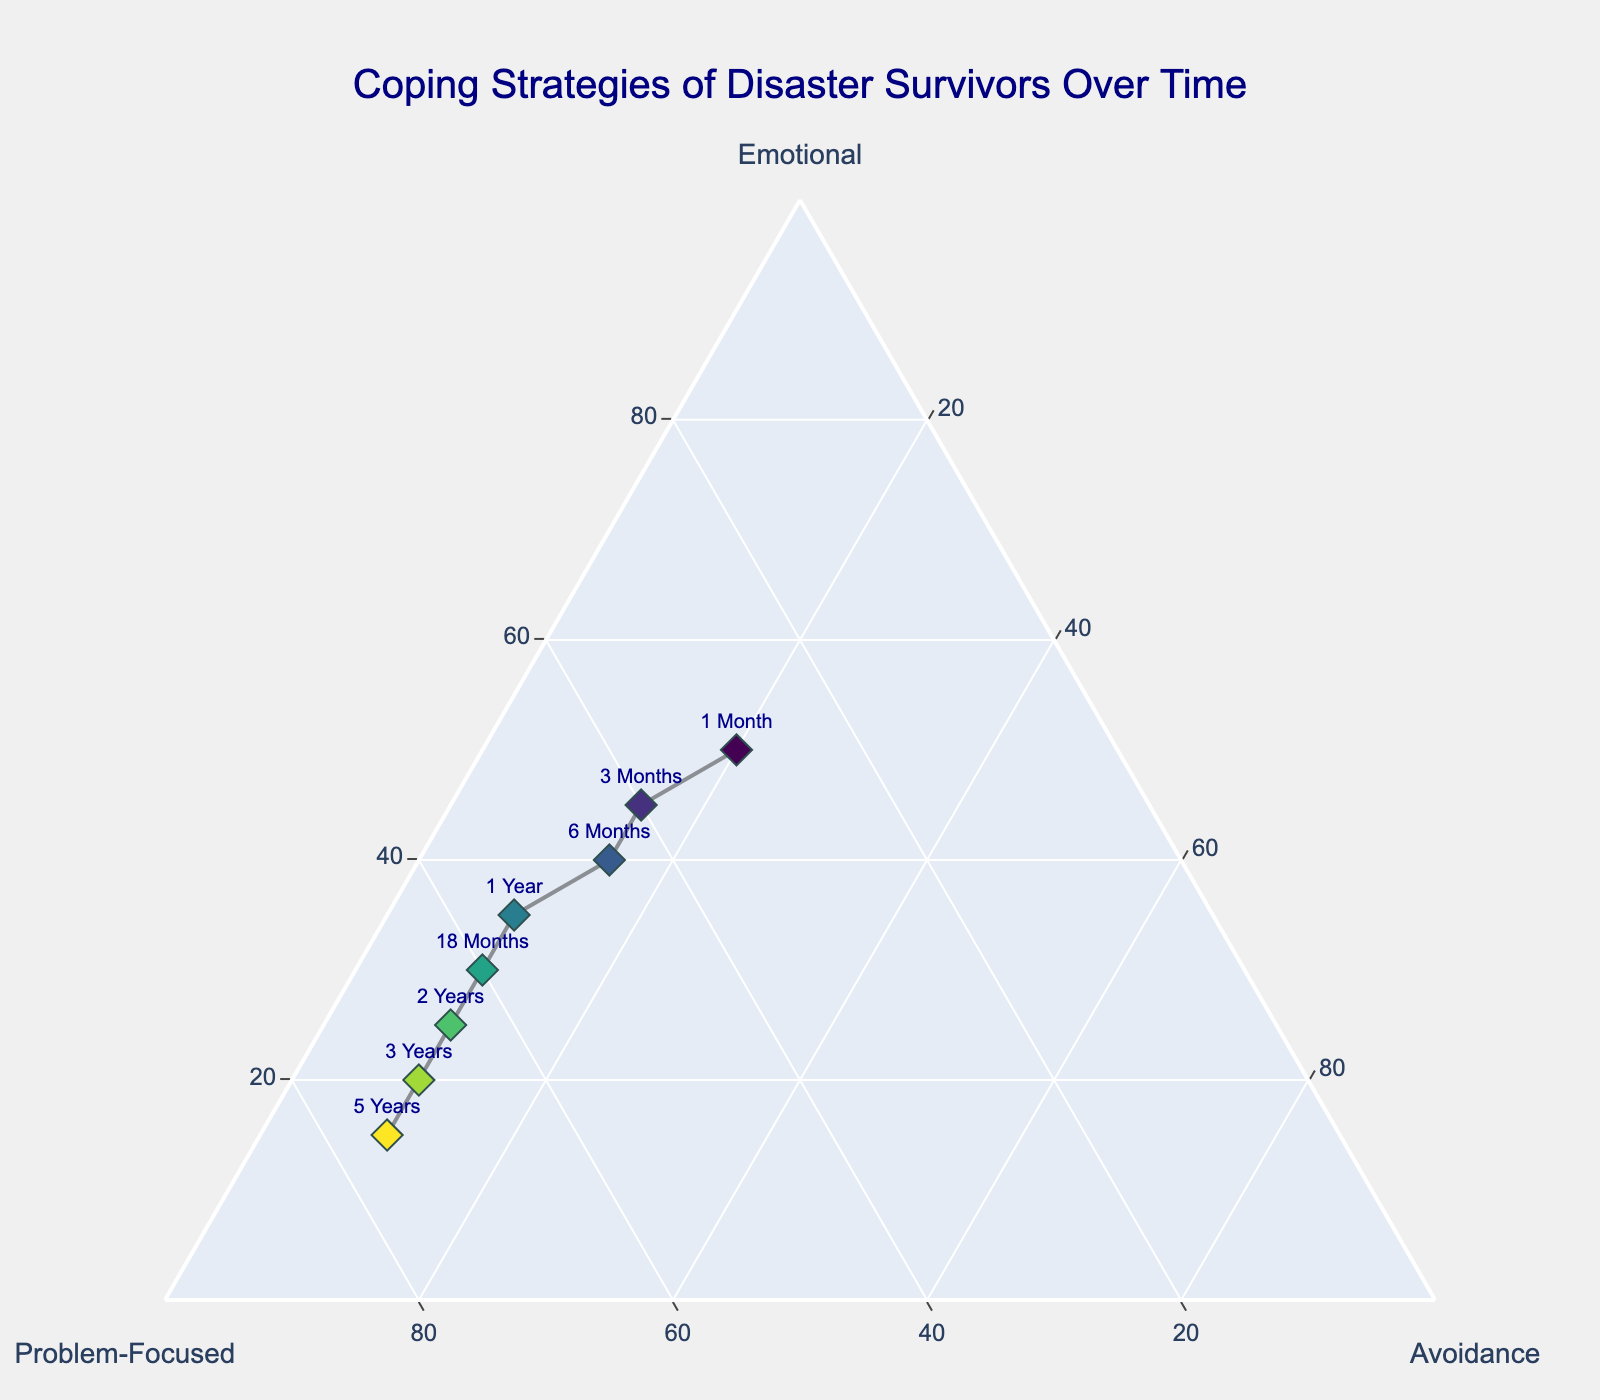What is the main title of the figure? The title is usually located at the top center of the plot. By reading the plot title, we get the main idea of the figure.
Answer: Coping Strategies of Disaster Survivors Over Time How many data points are shown in the figure? To find the number of data points, count the unique markers or labels on the ternary plot. By counting the time periods labeled on the plot, we can get the number.
Answer: 8 Which coping strategy shows the highest increase over time? By examining the trend lines in the plot, observe which strategy increases more over different time periods. "Problem-Focused" strategy shows consistent growth across the timeline.
Answer: Problem-Focused What is the distribution of coping strategies 1 year after the disaster? Refer to the point labeled "1 Year" in the plot and read the values for emotional, problem-focused, and avoidance strategies.
Answer: Emotional: 35, Problem-Focused: 55, Avoidance: 10 How does the emotional coping strategy change from 1 month to 3 years? Compare the values of emotional coping strategy between the points labeled "1 Month" and "3 Years". Subtract the value after 3 years from the value at 1 month. Emotional strategy at "1 Month" is 50 and at "3 Years" is 20. The change is 50 - 20 = 30.
Answer: Decreases by 30 Which coping strategy has the least variation over time? By visual inspection, check which of the three strategies shows the least change across all data points. Avoidance shows little deviation from its initial value.
Answer: Avoidance At what time period does the problem-focused strategy surpass the emotional strategy for the first time? Observe the plot and find the first time period where the problem-focused line crosses above the emotional line. This happens between "3 Months" and "6 Months".
Answer: 3 Months What is the combined total value of all coping strategies 6 months after the disaster? Sum the values for emotional, problem-focused, and avoidance strategies at the point labeled "6 Months". Emotional: 40, Problem-Focused: 45, Avoidance: 15. The total is 40 + 45 + 15 = 100.
Answer: 100 How do the values for avoidance in all time periods compare? Look at the avoidance values across all data points and identify any trends or consistencies. In this case, avoidance values only differ slightly around the value of 10 for most periods.
Answer: Mostly consistent around 10 What can be inferred about the distribution of strategies after 5 years? Refer to the point labeled "5 Years" and observe the relative positions of emotional, problem-focused, and avoidance strategies to infer their distribution. Emotional: 15, Problem-Focused: 75, Avoidance: 10. It's clear that problem-focused coping is dominant while emotional and avoidance are low.
Answer: Problem-Focused is dominant 